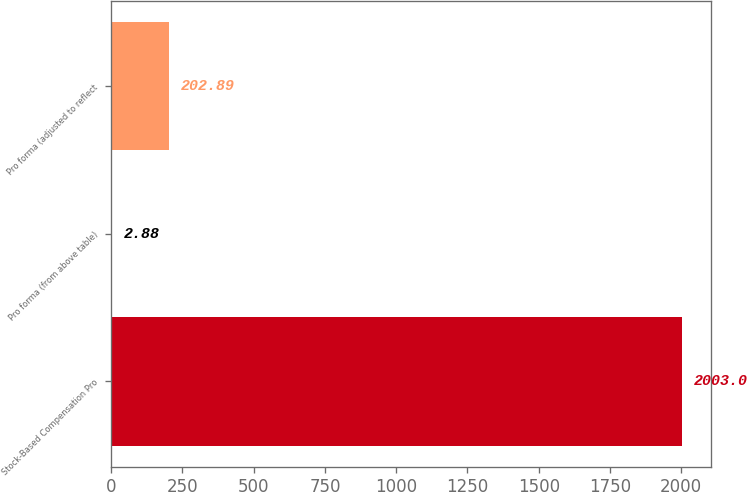Convert chart. <chart><loc_0><loc_0><loc_500><loc_500><bar_chart><fcel>Stock-Based Compensation Pro<fcel>Pro forma (from above table)<fcel>Pro forma (adjusted to reflect<nl><fcel>2003<fcel>2.88<fcel>202.89<nl></chart> 